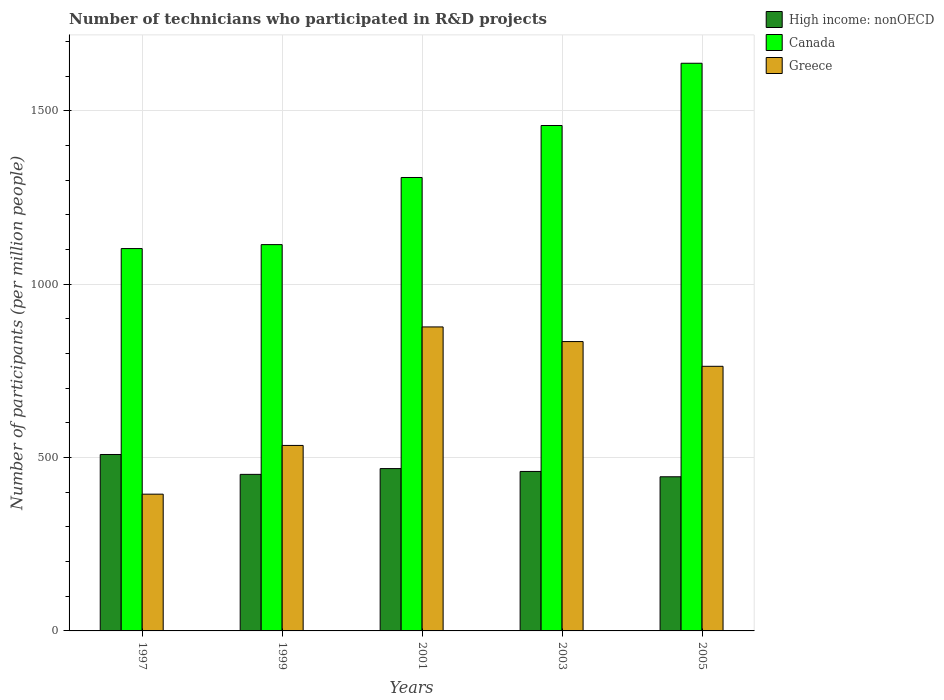How many different coloured bars are there?
Give a very brief answer. 3. Are the number of bars on each tick of the X-axis equal?
Your answer should be compact. Yes. What is the label of the 4th group of bars from the left?
Your response must be concise. 2003. In how many cases, is the number of bars for a given year not equal to the number of legend labels?
Your answer should be very brief. 0. What is the number of technicians who participated in R&D projects in Greece in 1997?
Offer a terse response. 394.52. Across all years, what is the maximum number of technicians who participated in R&D projects in High income: nonOECD?
Make the answer very short. 508.98. Across all years, what is the minimum number of technicians who participated in R&D projects in High income: nonOECD?
Your answer should be very brief. 444.7. What is the total number of technicians who participated in R&D projects in Greece in the graph?
Your response must be concise. 3404.79. What is the difference between the number of technicians who participated in R&D projects in Canada in 1997 and that in 1999?
Give a very brief answer. -11.38. What is the difference between the number of technicians who participated in R&D projects in Canada in 1997 and the number of technicians who participated in R&D projects in Greece in 1999?
Offer a terse response. 567.93. What is the average number of technicians who participated in R&D projects in High income: nonOECD per year?
Your response must be concise. 466.74. In the year 1997, what is the difference between the number of technicians who participated in R&D projects in Greece and number of technicians who participated in R&D projects in High income: nonOECD?
Provide a short and direct response. -114.46. What is the ratio of the number of technicians who participated in R&D projects in Canada in 1999 to that in 2003?
Offer a very short reply. 0.76. Is the number of technicians who participated in R&D projects in Greece in 1997 less than that in 1999?
Keep it short and to the point. Yes. Is the difference between the number of technicians who participated in R&D projects in Greece in 1999 and 2001 greater than the difference between the number of technicians who participated in R&D projects in High income: nonOECD in 1999 and 2001?
Keep it short and to the point. No. What is the difference between the highest and the second highest number of technicians who participated in R&D projects in High income: nonOECD?
Provide a succinct answer. 40.66. What is the difference between the highest and the lowest number of technicians who participated in R&D projects in Canada?
Provide a short and direct response. 534.59. Is the sum of the number of technicians who participated in R&D projects in High income: nonOECD in 1999 and 2003 greater than the maximum number of technicians who participated in R&D projects in Canada across all years?
Keep it short and to the point. No. Is it the case that in every year, the sum of the number of technicians who participated in R&D projects in Canada and number of technicians who participated in R&D projects in High income: nonOECD is greater than the number of technicians who participated in R&D projects in Greece?
Provide a short and direct response. Yes. Are all the bars in the graph horizontal?
Your answer should be compact. No. Does the graph contain grids?
Give a very brief answer. Yes. How are the legend labels stacked?
Your response must be concise. Vertical. What is the title of the graph?
Your answer should be compact. Number of technicians who participated in R&D projects. What is the label or title of the Y-axis?
Offer a very short reply. Number of participants (per million people). What is the Number of participants (per million people) of High income: nonOECD in 1997?
Make the answer very short. 508.98. What is the Number of participants (per million people) of Canada in 1997?
Your answer should be compact. 1103.07. What is the Number of participants (per million people) of Greece in 1997?
Provide a short and direct response. 394.52. What is the Number of participants (per million people) of High income: nonOECD in 1999?
Offer a very short reply. 451.63. What is the Number of participants (per million people) in Canada in 1999?
Provide a short and direct response. 1114.46. What is the Number of participants (per million people) of Greece in 1999?
Your response must be concise. 535.14. What is the Number of participants (per million people) of High income: nonOECD in 2001?
Offer a terse response. 468.32. What is the Number of participants (per million people) of Canada in 2001?
Provide a short and direct response. 1308.11. What is the Number of participants (per million people) in Greece in 2001?
Your answer should be compact. 877.01. What is the Number of participants (per million people) of High income: nonOECD in 2003?
Your response must be concise. 460.06. What is the Number of participants (per million people) of Canada in 2003?
Provide a succinct answer. 1458.07. What is the Number of participants (per million people) in Greece in 2003?
Provide a short and direct response. 834.74. What is the Number of participants (per million people) of High income: nonOECD in 2005?
Offer a very short reply. 444.7. What is the Number of participants (per million people) in Canada in 2005?
Ensure brevity in your answer.  1637.66. What is the Number of participants (per million people) of Greece in 2005?
Your answer should be very brief. 763.38. Across all years, what is the maximum Number of participants (per million people) of High income: nonOECD?
Your response must be concise. 508.98. Across all years, what is the maximum Number of participants (per million people) of Canada?
Ensure brevity in your answer.  1637.66. Across all years, what is the maximum Number of participants (per million people) of Greece?
Offer a terse response. 877.01. Across all years, what is the minimum Number of participants (per million people) of High income: nonOECD?
Give a very brief answer. 444.7. Across all years, what is the minimum Number of participants (per million people) in Canada?
Your answer should be very brief. 1103.07. Across all years, what is the minimum Number of participants (per million people) of Greece?
Ensure brevity in your answer.  394.52. What is the total Number of participants (per million people) in High income: nonOECD in the graph?
Offer a very short reply. 2333.69. What is the total Number of participants (per million people) in Canada in the graph?
Offer a terse response. 6621.37. What is the total Number of participants (per million people) in Greece in the graph?
Keep it short and to the point. 3404.79. What is the difference between the Number of participants (per million people) of High income: nonOECD in 1997 and that in 1999?
Offer a terse response. 57.35. What is the difference between the Number of participants (per million people) of Canada in 1997 and that in 1999?
Offer a very short reply. -11.38. What is the difference between the Number of participants (per million people) in Greece in 1997 and that in 1999?
Give a very brief answer. -140.62. What is the difference between the Number of participants (per million people) of High income: nonOECD in 1997 and that in 2001?
Your response must be concise. 40.66. What is the difference between the Number of participants (per million people) of Canada in 1997 and that in 2001?
Your answer should be compact. -205.03. What is the difference between the Number of participants (per million people) of Greece in 1997 and that in 2001?
Offer a very short reply. -482.49. What is the difference between the Number of participants (per million people) of High income: nonOECD in 1997 and that in 2003?
Provide a succinct answer. 48.93. What is the difference between the Number of participants (per million people) in Canada in 1997 and that in 2003?
Offer a terse response. -355. What is the difference between the Number of participants (per million people) of Greece in 1997 and that in 2003?
Your answer should be very brief. -440.22. What is the difference between the Number of participants (per million people) of High income: nonOECD in 1997 and that in 2005?
Offer a terse response. 64.28. What is the difference between the Number of participants (per million people) in Canada in 1997 and that in 2005?
Ensure brevity in your answer.  -534.59. What is the difference between the Number of participants (per million people) in Greece in 1997 and that in 2005?
Your response must be concise. -368.86. What is the difference between the Number of participants (per million people) in High income: nonOECD in 1999 and that in 2001?
Ensure brevity in your answer.  -16.69. What is the difference between the Number of participants (per million people) of Canada in 1999 and that in 2001?
Give a very brief answer. -193.65. What is the difference between the Number of participants (per million people) of Greece in 1999 and that in 2001?
Your answer should be very brief. -341.87. What is the difference between the Number of participants (per million people) in High income: nonOECD in 1999 and that in 2003?
Make the answer very short. -8.42. What is the difference between the Number of participants (per million people) in Canada in 1999 and that in 2003?
Keep it short and to the point. -343.61. What is the difference between the Number of participants (per million people) in Greece in 1999 and that in 2003?
Your answer should be very brief. -299.6. What is the difference between the Number of participants (per million people) in High income: nonOECD in 1999 and that in 2005?
Keep it short and to the point. 6.93. What is the difference between the Number of participants (per million people) of Canada in 1999 and that in 2005?
Your answer should be very brief. -523.21. What is the difference between the Number of participants (per million people) in Greece in 1999 and that in 2005?
Make the answer very short. -228.24. What is the difference between the Number of participants (per million people) of High income: nonOECD in 2001 and that in 2003?
Your answer should be compact. 8.27. What is the difference between the Number of participants (per million people) in Canada in 2001 and that in 2003?
Offer a terse response. -149.96. What is the difference between the Number of participants (per million people) of Greece in 2001 and that in 2003?
Make the answer very short. 42.27. What is the difference between the Number of participants (per million people) in High income: nonOECD in 2001 and that in 2005?
Provide a succinct answer. 23.62. What is the difference between the Number of participants (per million people) of Canada in 2001 and that in 2005?
Offer a very short reply. -329.56. What is the difference between the Number of participants (per million people) in Greece in 2001 and that in 2005?
Keep it short and to the point. 113.63. What is the difference between the Number of participants (per million people) of High income: nonOECD in 2003 and that in 2005?
Your response must be concise. 15.35. What is the difference between the Number of participants (per million people) of Canada in 2003 and that in 2005?
Give a very brief answer. -179.59. What is the difference between the Number of participants (per million people) in Greece in 2003 and that in 2005?
Keep it short and to the point. 71.35. What is the difference between the Number of participants (per million people) of High income: nonOECD in 1997 and the Number of participants (per million people) of Canada in 1999?
Your answer should be compact. -605.47. What is the difference between the Number of participants (per million people) in High income: nonOECD in 1997 and the Number of participants (per million people) in Greece in 1999?
Make the answer very short. -26.16. What is the difference between the Number of participants (per million people) of Canada in 1997 and the Number of participants (per million people) of Greece in 1999?
Give a very brief answer. 567.93. What is the difference between the Number of participants (per million people) of High income: nonOECD in 1997 and the Number of participants (per million people) of Canada in 2001?
Your answer should be compact. -799.13. What is the difference between the Number of participants (per million people) in High income: nonOECD in 1997 and the Number of participants (per million people) in Greece in 2001?
Offer a very short reply. -368.03. What is the difference between the Number of participants (per million people) in Canada in 1997 and the Number of participants (per million people) in Greece in 2001?
Your answer should be very brief. 226.06. What is the difference between the Number of participants (per million people) of High income: nonOECD in 1997 and the Number of participants (per million people) of Canada in 2003?
Offer a terse response. -949.09. What is the difference between the Number of participants (per million people) in High income: nonOECD in 1997 and the Number of participants (per million people) in Greece in 2003?
Provide a short and direct response. -325.76. What is the difference between the Number of participants (per million people) in Canada in 1997 and the Number of participants (per million people) in Greece in 2003?
Provide a succinct answer. 268.34. What is the difference between the Number of participants (per million people) in High income: nonOECD in 1997 and the Number of participants (per million people) in Canada in 2005?
Offer a terse response. -1128.68. What is the difference between the Number of participants (per million people) in High income: nonOECD in 1997 and the Number of participants (per million people) in Greece in 2005?
Keep it short and to the point. -254.4. What is the difference between the Number of participants (per million people) in Canada in 1997 and the Number of participants (per million people) in Greece in 2005?
Your answer should be very brief. 339.69. What is the difference between the Number of participants (per million people) of High income: nonOECD in 1999 and the Number of participants (per million people) of Canada in 2001?
Your answer should be compact. -856.47. What is the difference between the Number of participants (per million people) in High income: nonOECD in 1999 and the Number of participants (per million people) in Greece in 2001?
Keep it short and to the point. -425.38. What is the difference between the Number of participants (per million people) of Canada in 1999 and the Number of participants (per million people) of Greece in 2001?
Your response must be concise. 237.44. What is the difference between the Number of participants (per million people) in High income: nonOECD in 1999 and the Number of participants (per million people) in Canada in 2003?
Offer a very short reply. -1006.44. What is the difference between the Number of participants (per million people) in High income: nonOECD in 1999 and the Number of participants (per million people) in Greece in 2003?
Offer a very short reply. -383.11. What is the difference between the Number of participants (per million people) in Canada in 1999 and the Number of participants (per million people) in Greece in 2003?
Provide a succinct answer. 279.72. What is the difference between the Number of participants (per million people) of High income: nonOECD in 1999 and the Number of participants (per million people) of Canada in 2005?
Keep it short and to the point. -1186.03. What is the difference between the Number of participants (per million people) in High income: nonOECD in 1999 and the Number of participants (per million people) in Greece in 2005?
Your response must be concise. -311.75. What is the difference between the Number of participants (per million people) in Canada in 1999 and the Number of participants (per million people) in Greece in 2005?
Ensure brevity in your answer.  351.07. What is the difference between the Number of participants (per million people) of High income: nonOECD in 2001 and the Number of participants (per million people) of Canada in 2003?
Ensure brevity in your answer.  -989.75. What is the difference between the Number of participants (per million people) of High income: nonOECD in 2001 and the Number of participants (per million people) of Greece in 2003?
Offer a very short reply. -366.42. What is the difference between the Number of participants (per million people) of Canada in 2001 and the Number of participants (per million people) of Greece in 2003?
Your answer should be very brief. 473.37. What is the difference between the Number of participants (per million people) of High income: nonOECD in 2001 and the Number of participants (per million people) of Canada in 2005?
Offer a terse response. -1169.34. What is the difference between the Number of participants (per million people) in High income: nonOECD in 2001 and the Number of participants (per million people) in Greece in 2005?
Keep it short and to the point. -295.06. What is the difference between the Number of participants (per million people) of Canada in 2001 and the Number of participants (per million people) of Greece in 2005?
Offer a terse response. 544.72. What is the difference between the Number of participants (per million people) in High income: nonOECD in 2003 and the Number of participants (per million people) in Canada in 2005?
Provide a short and direct response. -1177.61. What is the difference between the Number of participants (per million people) of High income: nonOECD in 2003 and the Number of participants (per million people) of Greece in 2005?
Offer a terse response. -303.33. What is the difference between the Number of participants (per million people) in Canada in 2003 and the Number of participants (per million people) in Greece in 2005?
Make the answer very short. 694.69. What is the average Number of participants (per million people) in High income: nonOECD per year?
Your answer should be very brief. 466.74. What is the average Number of participants (per million people) in Canada per year?
Provide a succinct answer. 1324.27. What is the average Number of participants (per million people) of Greece per year?
Ensure brevity in your answer.  680.96. In the year 1997, what is the difference between the Number of participants (per million people) in High income: nonOECD and Number of participants (per million people) in Canada?
Offer a very short reply. -594.09. In the year 1997, what is the difference between the Number of participants (per million people) in High income: nonOECD and Number of participants (per million people) in Greece?
Offer a very short reply. 114.46. In the year 1997, what is the difference between the Number of participants (per million people) in Canada and Number of participants (per million people) in Greece?
Your answer should be very brief. 708.55. In the year 1999, what is the difference between the Number of participants (per million people) in High income: nonOECD and Number of participants (per million people) in Canada?
Keep it short and to the point. -662.82. In the year 1999, what is the difference between the Number of participants (per million people) in High income: nonOECD and Number of participants (per million people) in Greece?
Make the answer very short. -83.51. In the year 1999, what is the difference between the Number of participants (per million people) in Canada and Number of participants (per million people) in Greece?
Give a very brief answer. 579.32. In the year 2001, what is the difference between the Number of participants (per million people) of High income: nonOECD and Number of participants (per million people) of Canada?
Your answer should be compact. -839.79. In the year 2001, what is the difference between the Number of participants (per million people) in High income: nonOECD and Number of participants (per million people) in Greece?
Your response must be concise. -408.69. In the year 2001, what is the difference between the Number of participants (per million people) in Canada and Number of participants (per million people) in Greece?
Ensure brevity in your answer.  431.1. In the year 2003, what is the difference between the Number of participants (per million people) in High income: nonOECD and Number of participants (per million people) in Canada?
Keep it short and to the point. -998.01. In the year 2003, what is the difference between the Number of participants (per million people) in High income: nonOECD and Number of participants (per million people) in Greece?
Make the answer very short. -374.68. In the year 2003, what is the difference between the Number of participants (per million people) in Canada and Number of participants (per million people) in Greece?
Your response must be concise. 623.33. In the year 2005, what is the difference between the Number of participants (per million people) of High income: nonOECD and Number of participants (per million people) of Canada?
Ensure brevity in your answer.  -1192.96. In the year 2005, what is the difference between the Number of participants (per million people) of High income: nonOECD and Number of participants (per million people) of Greece?
Provide a succinct answer. -318.68. In the year 2005, what is the difference between the Number of participants (per million people) of Canada and Number of participants (per million people) of Greece?
Your answer should be very brief. 874.28. What is the ratio of the Number of participants (per million people) in High income: nonOECD in 1997 to that in 1999?
Your response must be concise. 1.13. What is the ratio of the Number of participants (per million people) of Greece in 1997 to that in 1999?
Offer a very short reply. 0.74. What is the ratio of the Number of participants (per million people) in High income: nonOECD in 1997 to that in 2001?
Ensure brevity in your answer.  1.09. What is the ratio of the Number of participants (per million people) of Canada in 1997 to that in 2001?
Provide a succinct answer. 0.84. What is the ratio of the Number of participants (per million people) in Greece in 1997 to that in 2001?
Your response must be concise. 0.45. What is the ratio of the Number of participants (per million people) of High income: nonOECD in 1997 to that in 2003?
Your answer should be compact. 1.11. What is the ratio of the Number of participants (per million people) of Canada in 1997 to that in 2003?
Your answer should be very brief. 0.76. What is the ratio of the Number of participants (per million people) in Greece in 1997 to that in 2003?
Ensure brevity in your answer.  0.47. What is the ratio of the Number of participants (per million people) of High income: nonOECD in 1997 to that in 2005?
Your answer should be very brief. 1.14. What is the ratio of the Number of participants (per million people) in Canada in 1997 to that in 2005?
Provide a short and direct response. 0.67. What is the ratio of the Number of participants (per million people) in Greece in 1997 to that in 2005?
Your answer should be compact. 0.52. What is the ratio of the Number of participants (per million people) of High income: nonOECD in 1999 to that in 2001?
Your answer should be very brief. 0.96. What is the ratio of the Number of participants (per million people) in Canada in 1999 to that in 2001?
Ensure brevity in your answer.  0.85. What is the ratio of the Number of participants (per million people) of Greece in 1999 to that in 2001?
Your response must be concise. 0.61. What is the ratio of the Number of participants (per million people) in High income: nonOECD in 1999 to that in 2003?
Offer a very short reply. 0.98. What is the ratio of the Number of participants (per million people) of Canada in 1999 to that in 2003?
Give a very brief answer. 0.76. What is the ratio of the Number of participants (per million people) in Greece in 1999 to that in 2003?
Ensure brevity in your answer.  0.64. What is the ratio of the Number of participants (per million people) of High income: nonOECD in 1999 to that in 2005?
Your answer should be very brief. 1.02. What is the ratio of the Number of participants (per million people) in Canada in 1999 to that in 2005?
Your answer should be very brief. 0.68. What is the ratio of the Number of participants (per million people) in Greece in 1999 to that in 2005?
Your answer should be very brief. 0.7. What is the ratio of the Number of participants (per million people) in Canada in 2001 to that in 2003?
Ensure brevity in your answer.  0.9. What is the ratio of the Number of participants (per million people) of Greece in 2001 to that in 2003?
Provide a succinct answer. 1.05. What is the ratio of the Number of participants (per million people) of High income: nonOECD in 2001 to that in 2005?
Give a very brief answer. 1.05. What is the ratio of the Number of participants (per million people) in Canada in 2001 to that in 2005?
Your answer should be compact. 0.8. What is the ratio of the Number of participants (per million people) in Greece in 2001 to that in 2005?
Provide a short and direct response. 1.15. What is the ratio of the Number of participants (per million people) of High income: nonOECD in 2003 to that in 2005?
Your answer should be very brief. 1.03. What is the ratio of the Number of participants (per million people) of Canada in 2003 to that in 2005?
Offer a very short reply. 0.89. What is the ratio of the Number of participants (per million people) in Greece in 2003 to that in 2005?
Ensure brevity in your answer.  1.09. What is the difference between the highest and the second highest Number of participants (per million people) of High income: nonOECD?
Make the answer very short. 40.66. What is the difference between the highest and the second highest Number of participants (per million people) in Canada?
Provide a succinct answer. 179.59. What is the difference between the highest and the second highest Number of participants (per million people) in Greece?
Your answer should be compact. 42.27. What is the difference between the highest and the lowest Number of participants (per million people) of High income: nonOECD?
Give a very brief answer. 64.28. What is the difference between the highest and the lowest Number of participants (per million people) in Canada?
Provide a succinct answer. 534.59. What is the difference between the highest and the lowest Number of participants (per million people) in Greece?
Your response must be concise. 482.49. 